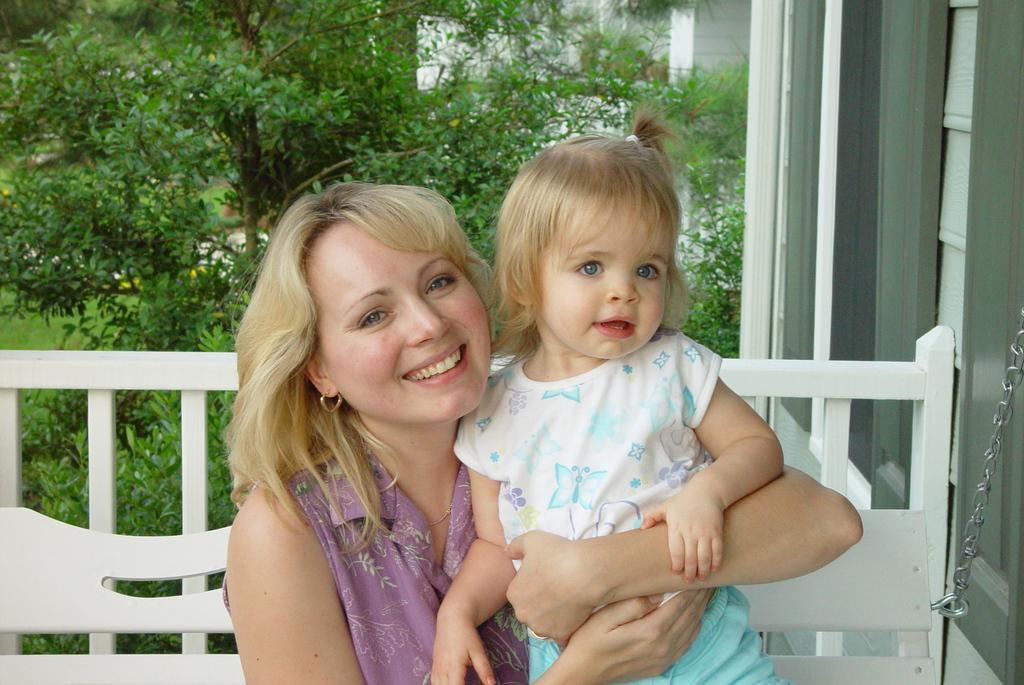Describe this image in one or two sentences. In this image there is a lady and a girl sitting on the bench, in the background there are trees, on the right side there is a wall. 